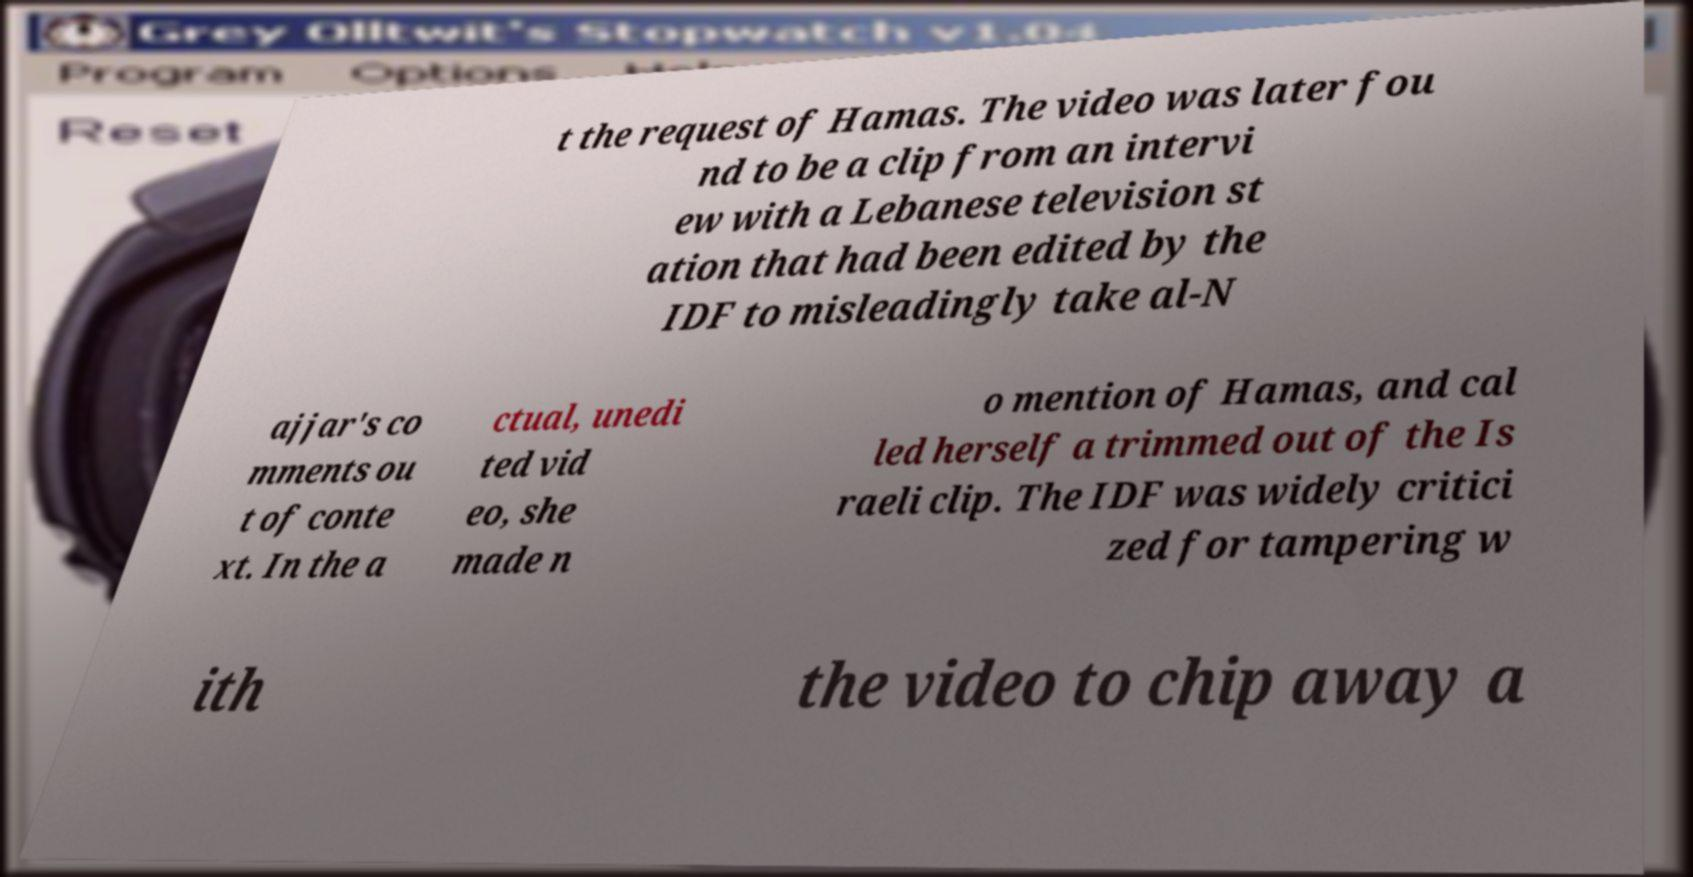I need the written content from this picture converted into text. Can you do that? t the request of Hamas. The video was later fou nd to be a clip from an intervi ew with a Lebanese television st ation that had been edited by the IDF to misleadingly take al-N ajjar's co mments ou t of conte xt. In the a ctual, unedi ted vid eo, she made n o mention of Hamas, and cal led herself a trimmed out of the Is raeli clip. The IDF was widely critici zed for tampering w ith the video to chip away a 